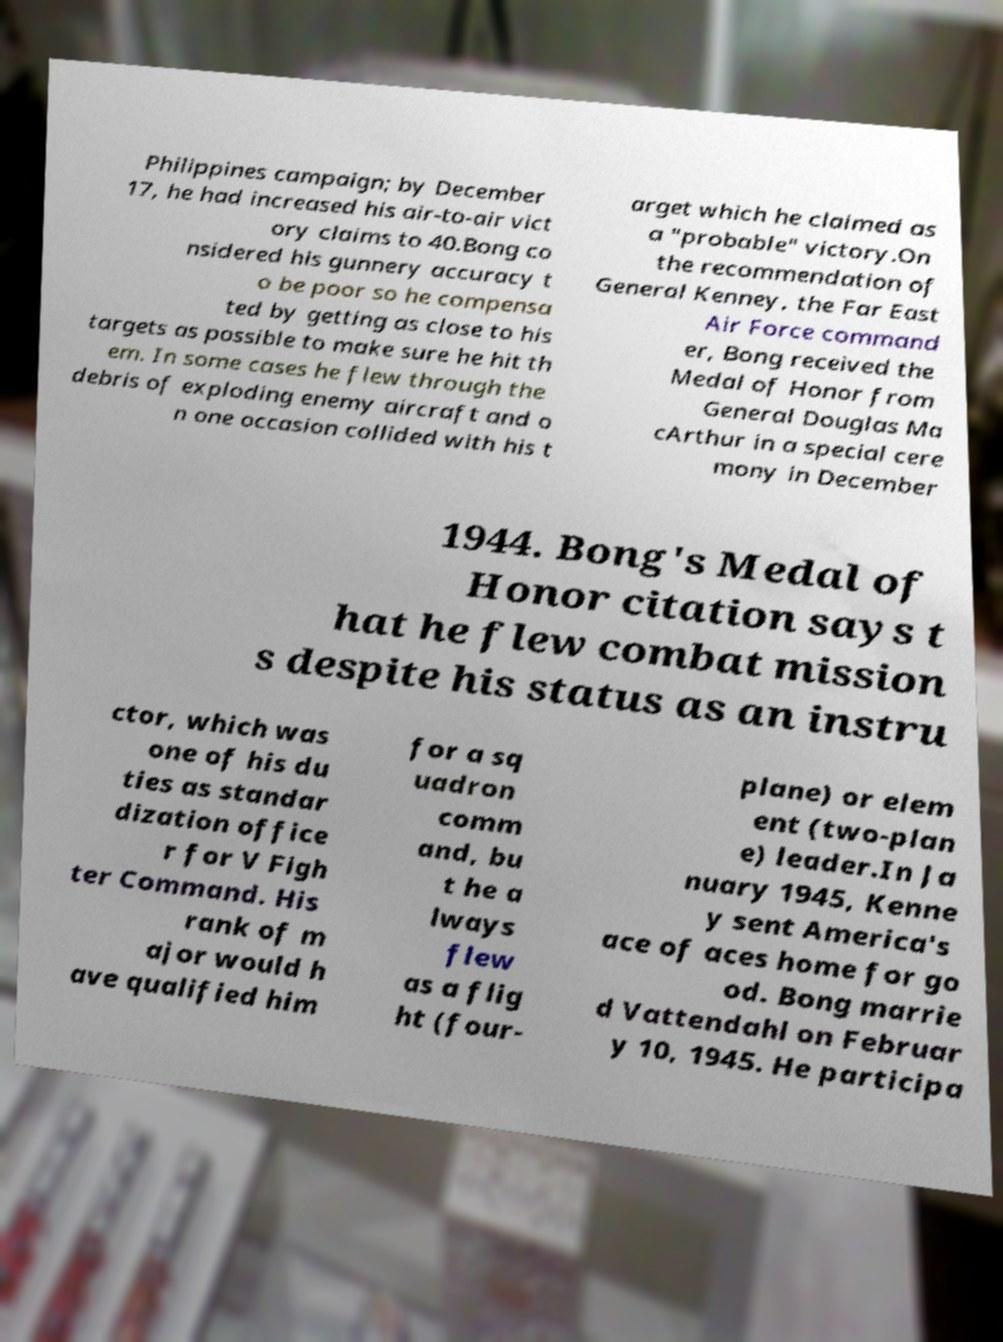There's text embedded in this image that I need extracted. Can you transcribe it verbatim? Philippines campaign; by December 17, he had increased his air-to-air vict ory claims to 40.Bong co nsidered his gunnery accuracy t o be poor so he compensa ted by getting as close to his targets as possible to make sure he hit th em. In some cases he flew through the debris of exploding enemy aircraft and o n one occasion collided with his t arget which he claimed as a "probable" victory.On the recommendation of General Kenney, the Far East Air Force command er, Bong received the Medal of Honor from General Douglas Ma cArthur in a special cere mony in December 1944. Bong's Medal of Honor citation says t hat he flew combat mission s despite his status as an instru ctor, which was one of his du ties as standar dization office r for V Figh ter Command. His rank of m ajor would h ave qualified him for a sq uadron comm and, bu t he a lways flew as a flig ht (four- plane) or elem ent (two-plan e) leader.In Ja nuary 1945, Kenne y sent America's ace of aces home for go od. Bong marrie d Vattendahl on Februar y 10, 1945. He participa 